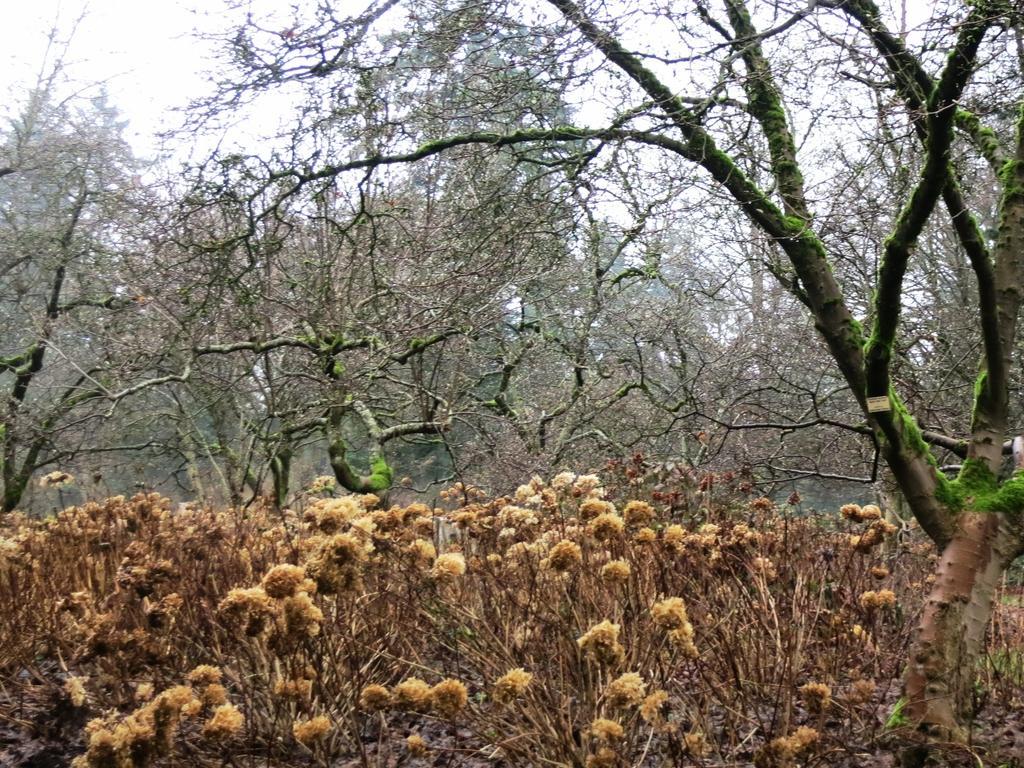Please provide a concise description of this image. In this image we can see plants, trees and in the background of the image there is clear sky. 